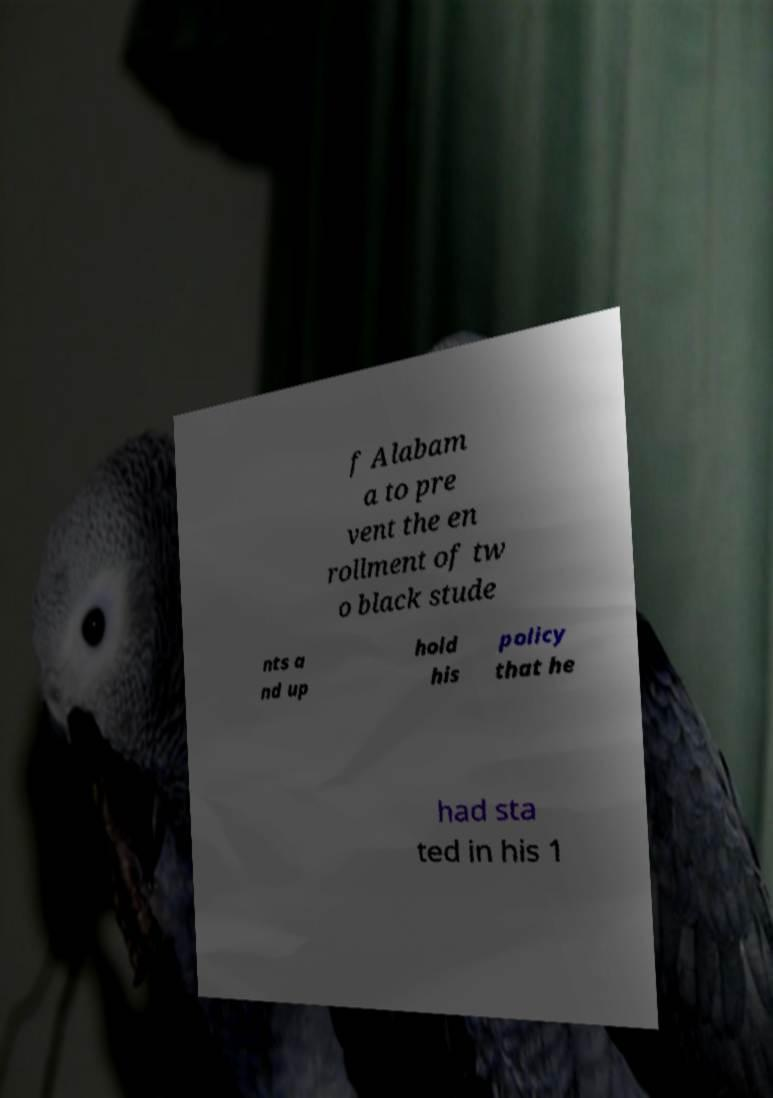There's text embedded in this image that I need extracted. Can you transcribe it verbatim? f Alabam a to pre vent the en rollment of tw o black stude nts a nd up hold his policy that he had sta ted in his 1 